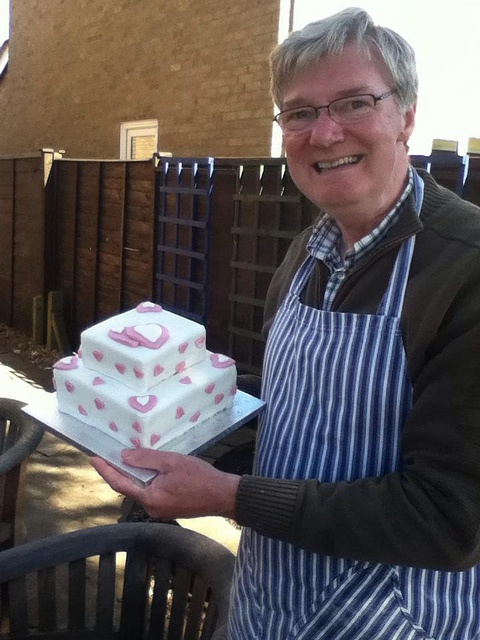Describe the objects in this image and their specific colors. I can see people in ivory, black, gray, and navy tones, chair in ivory, black, and gray tones, cake in ivory, lightgray, darkgray, and lightblue tones, and chair in ivory, black, and gray tones in this image. 